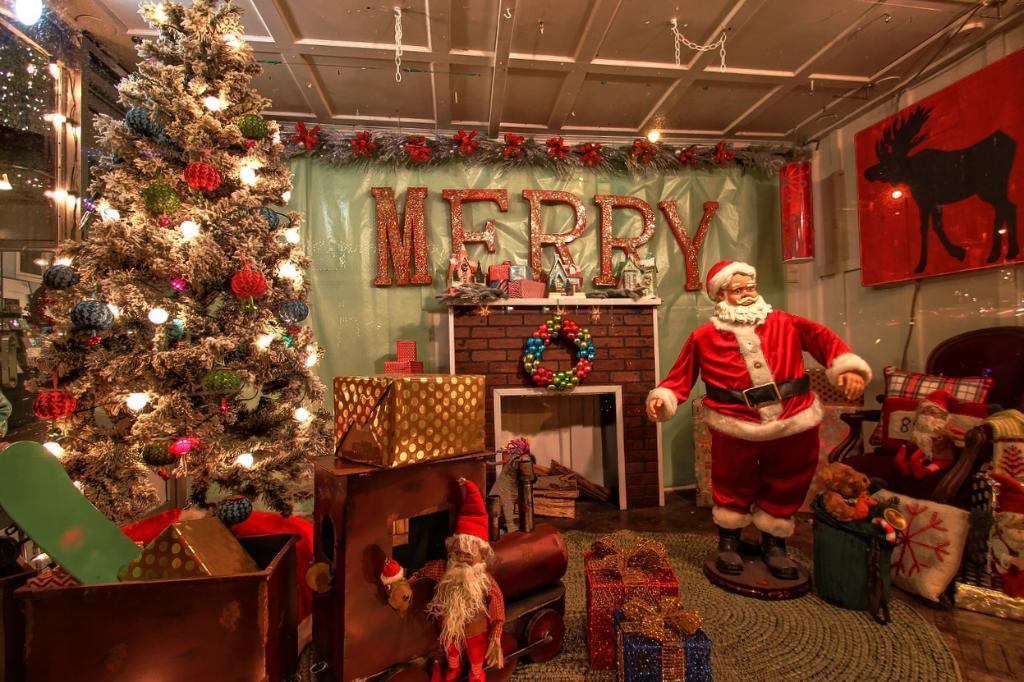Can you describe this image briefly? In this image, we can see a christmas tree with some decorative items. At the bottom, we can see few gift boxes, vehicle, some toys. Right side of the image, we can see a santa claus statue, Teddy bears, pillows, chair, few things. Background there is a banner, fireplace, some decorative pieces are placed on the shelf. Here we can see a board. Top of the image, there is a roof with chains and light. At the bottom, there is a floor mat on the floor. 